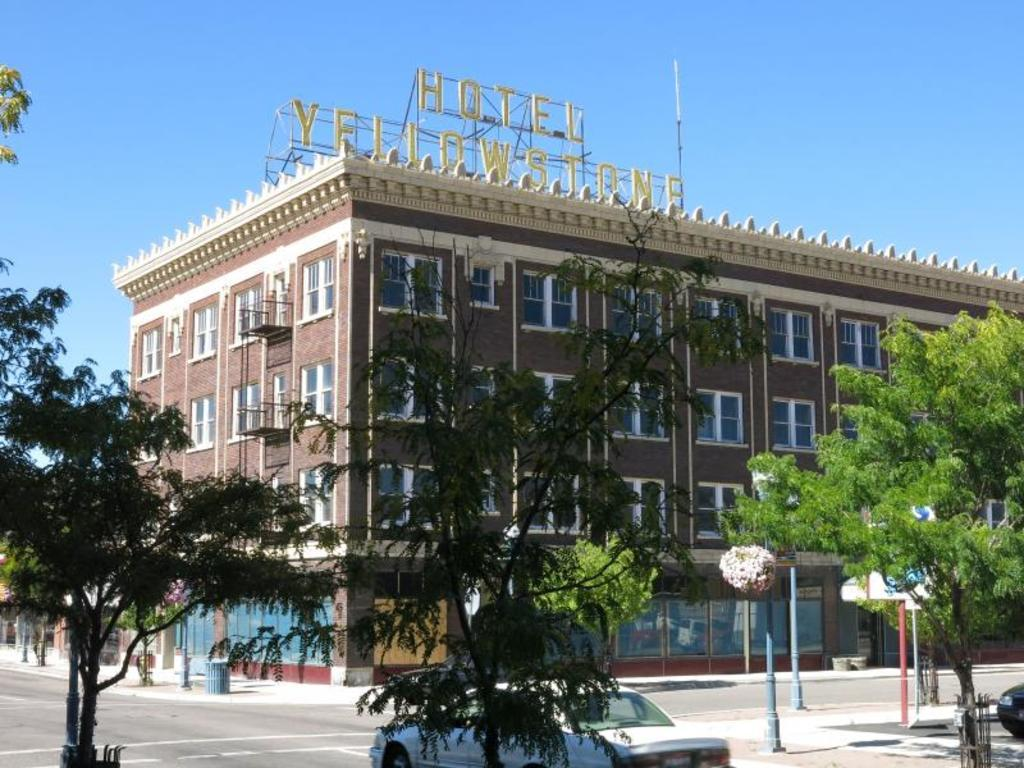What type of structure is visible in the image? There is a building with windows in the image. What other natural elements can be seen in the image? There are trees in the image. What is happening on the road in the image? Vehicles are present on the road in the image. What are the vertical structures in the image? There are poles in the image. What is visible in the background of the image? The sky is visible in the background of the image. What type of juice is being served at the place in the image? There is no place or juice present in the image; it features a building, trees, vehicles, poles, and the sky. How many knees are visible in the image? There are no knees visible in the image. 